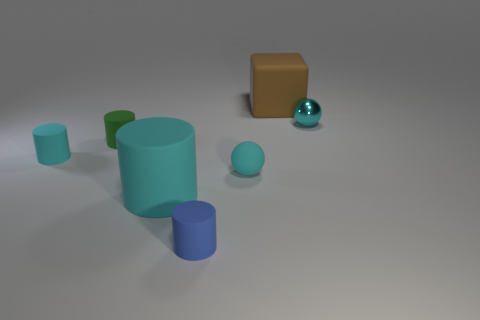Is there any other thing that has the same color as the big rubber block?
Offer a very short reply. No. What number of other things are the same size as the green object?
Ensure brevity in your answer.  4. Is the color of the ball that is to the right of the tiny rubber ball the same as the sphere that is left of the big brown rubber object?
Your answer should be compact. Yes. The matte thing that is both right of the tiny blue thing and to the left of the big brown thing is what color?
Ensure brevity in your answer.  Cyan. What number of other objects are there of the same shape as the small green object?
Give a very brief answer. 3. What color is the matte ball that is the same size as the blue matte object?
Provide a short and direct response. Cyan. There is a large thing that is right of the blue object; what is its color?
Keep it short and to the point. Brown. There is a tiny cyan ball on the right side of the large block; are there any small green things left of it?
Offer a very short reply. Yes. There is a large brown matte object; is it the same shape as the cyan rubber object left of the tiny green object?
Your response must be concise. No. How big is the thing that is right of the small cyan rubber ball and in front of the large brown matte thing?
Make the answer very short. Small. 